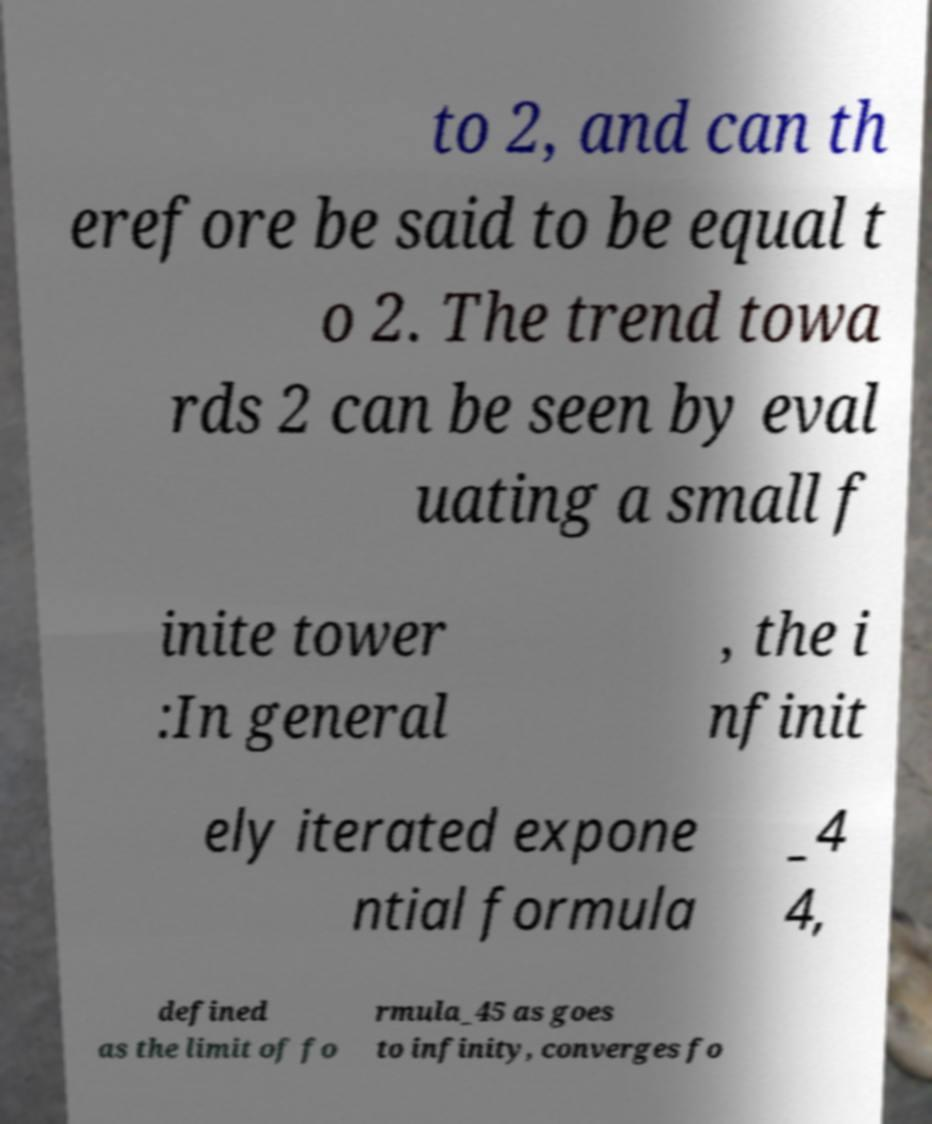Could you extract and type out the text from this image? to 2, and can th erefore be said to be equal t o 2. The trend towa rds 2 can be seen by eval uating a small f inite tower :In general , the i nfinit ely iterated expone ntial formula _4 4, defined as the limit of fo rmula_45 as goes to infinity, converges fo 